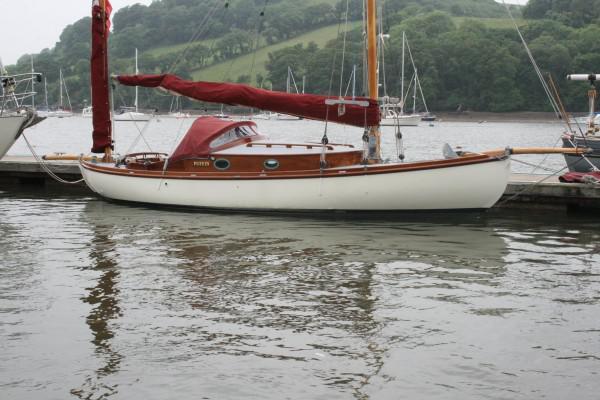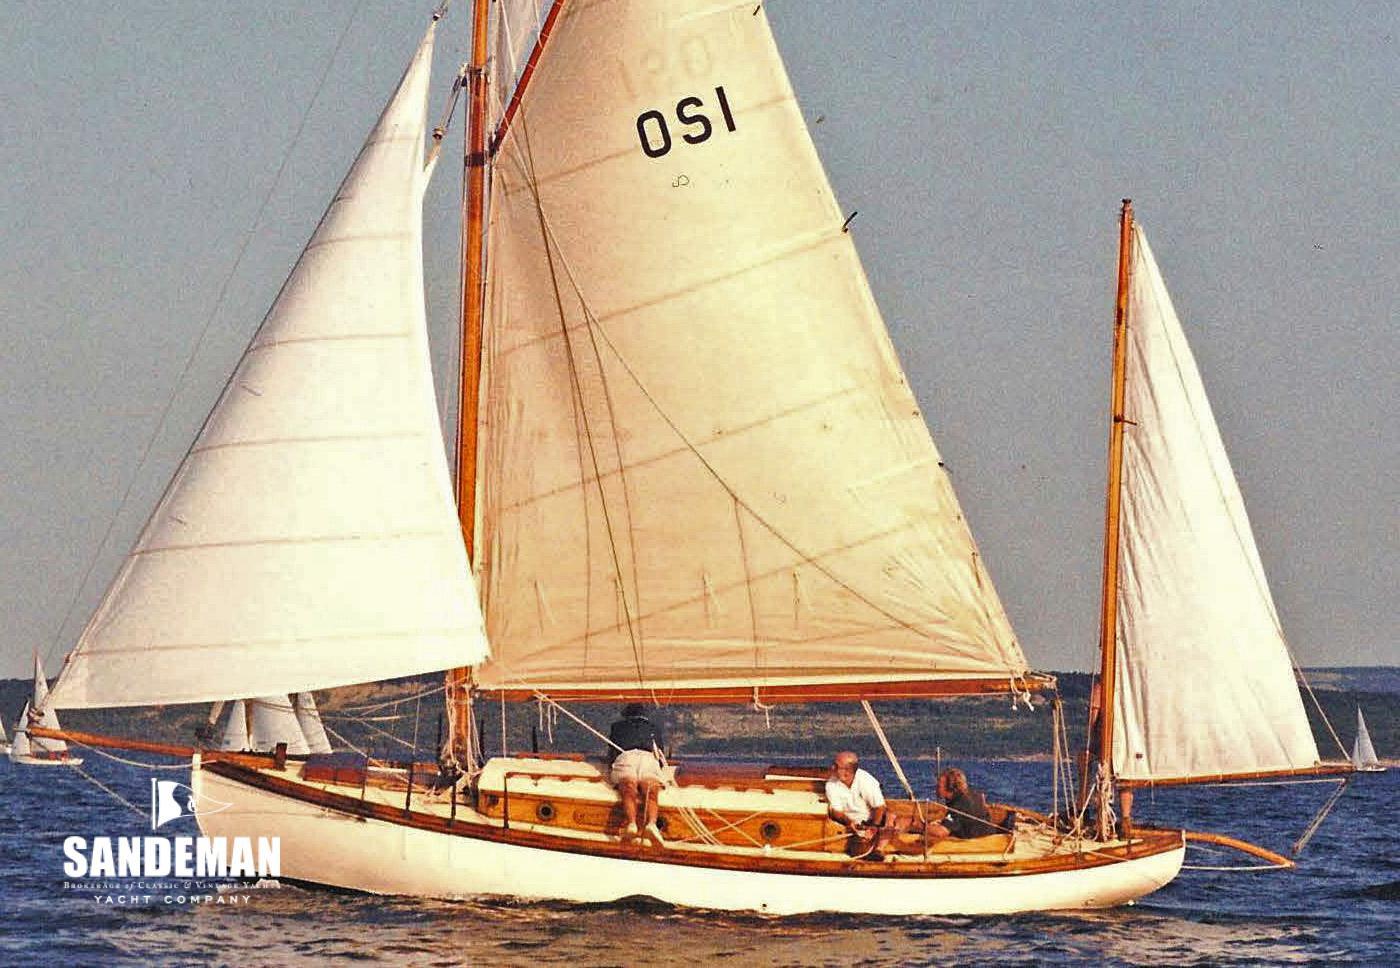The first image is the image on the left, the second image is the image on the right. For the images shown, is this caption "The left and right image contains the same number sailboats with at least one boat with its sails down." true? Answer yes or no. Yes. The first image is the image on the left, the second image is the image on the right. For the images displayed, is the sentence "The sails in the left image are closed." factually correct? Answer yes or no. Yes. 